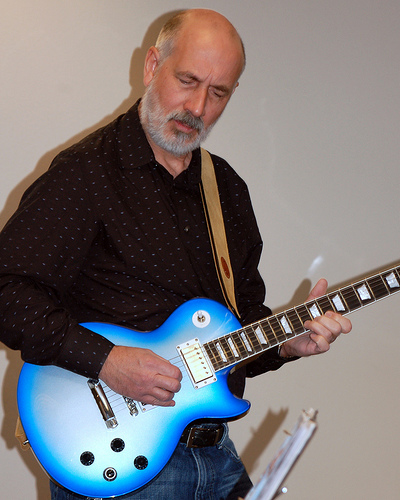<image>
Is there a guitarist under the wall? No. The guitarist is not positioned under the wall. The vertical relationship between these objects is different. 